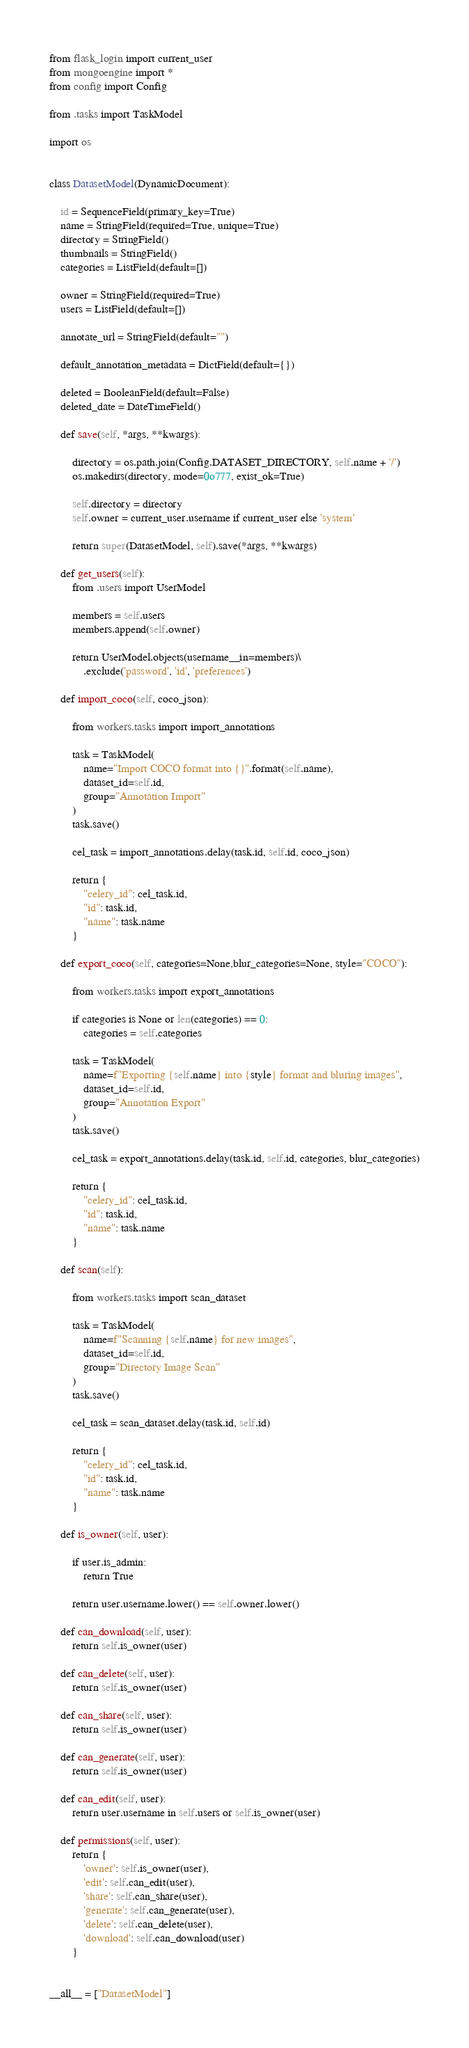Convert code to text. <code><loc_0><loc_0><loc_500><loc_500><_Python_>
from flask_login import current_user
from mongoengine import *
from config import Config

from .tasks import TaskModel

import os


class DatasetModel(DynamicDocument):
    
    id = SequenceField(primary_key=True)
    name = StringField(required=True, unique=True)
    directory = StringField()
    thumbnails = StringField()
    categories = ListField(default=[])

    owner = StringField(required=True)
    users = ListField(default=[])

    annotate_url = StringField(default="")

    default_annotation_metadata = DictField(default={})

    deleted = BooleanField(default=False)
    deleted_date = DateTimeField()

    def save(self, *args, **kwargs):

        directory = os.path.join(Config.DATASET_DIRECTORY, self.name + '/')
        os.makedirs(directory, mode=0o777, exist_ok=True)

        self.directory = directory
        self.owner = current_user.username if current_user else 'system'

        return super(DatasetModel, self).save(*args, **kwargs)

    def get_users(self):
        from .users import UserModel
    
        members = self.users
        members.append(self.owner)

        return UserModel.objects(username__in=members)\
            .exclude('password', 'id', 'preferences')

    def import_coco(self, coco_json):

        from workers.tasks import import_annotations

        task = TaskModel(
            name="Import COCO format into {}".format(self.name),
            dataset_id=self.id,
            group="Annotation Import"
        )
        task.save()

        cel_task = import_annotations.delay(task.id, self.id, coco_json)

        return {
            "celery_id": cel_task.id,
            "id": task.id,
            "name": task.name
        }

    def export_coco(self, categories=None,blur_categories=None, style="COCO"):

        from workers.tasks import export_annotations

        if categories is None or len(categories) == 0:
            categories = self.categories
        
        task = TaskModel(
            name=f"Exporting {self.name} into {style} format and bluring images",
            dataset_id=self.id,
            group="Annotation Export"
        )
        task.save()

        cel_task = export_annotations.delay(task.id, self.id, categories, blur_categories)

        return {
            "celery_id": cel_task.id,
            "id": task.id,
            "name": task.name
        }

    def scan(self):

        from workers.tasks import scan_dataset
        
        task = TaskModel(
            name=f"Scanning {self.name} for new images",
            dataset_id=self.id,
            group="Directory Image Scan"
        )
        task.save()
        
        cel_task = scan_dataset.delay(task.id, self.id)

        return {
            "celery_id": cel_task.id,
            "id": task.id,
            "name": task.name
        }

    def is_owner(self, user):

        if user.is_admin:
            return True
        
        return user.username.lower() == self.owner.lower()

    def can_download(self, user):
        return self.is_owner(user)

    def can_delete(self, user):
        return self.is_owner(user)
    
    def can_share(self, user):
        return self.is_owner(user)
    
    def can_generate(self, user):
        return self.is_owner(user)

    def can_edit(self, user):
        return user.username in self.users or self.is_owner(user)
    
    def permissions(self, user):
        return {
            'owner': self.is_owner(user),
            'edit': self.can_edit(user),
            'share': self.can_share(user),
            'generate': self.can_generate(user),
            'delete': self.can_delete(user),
            'download': self.can_download(user)
        }


__all__ = ["DatasetModel"]
</code> 